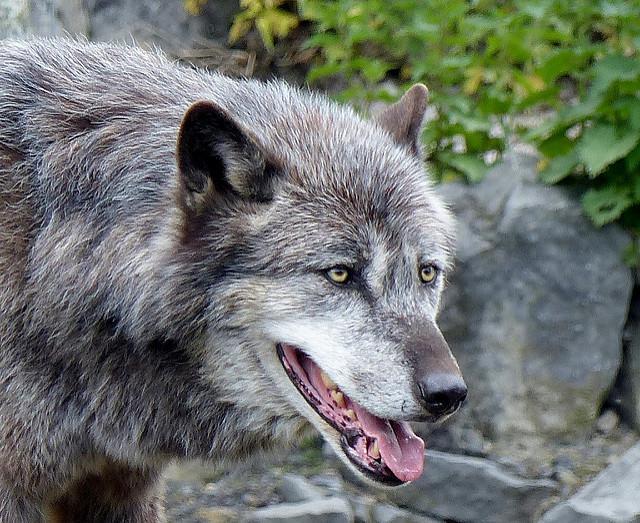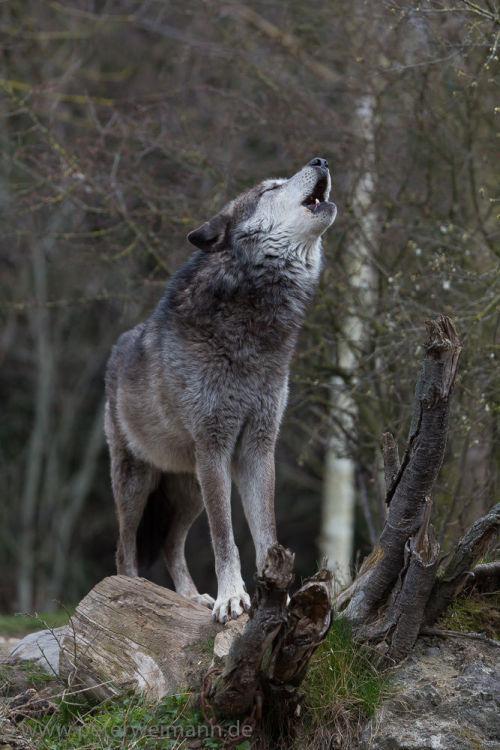The first image is the image on the left, the second image is the image on the right. Examine the images to the left and right. Is the description "The right image includes a rightward-turned wolf with its head and neck raised, eyes closed, and mouth open in a howling pose." accurate? Answer yes or no. Yes. 